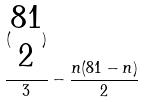<formula> <loc_0><loc_0><loc_500><loc_500>\frac { ( \begin{matrix} 8 1 \\ 2 \end{matrix} ) } { 3 } - \frac { n ( 8 1 - n ) } { 2 }</formula> 